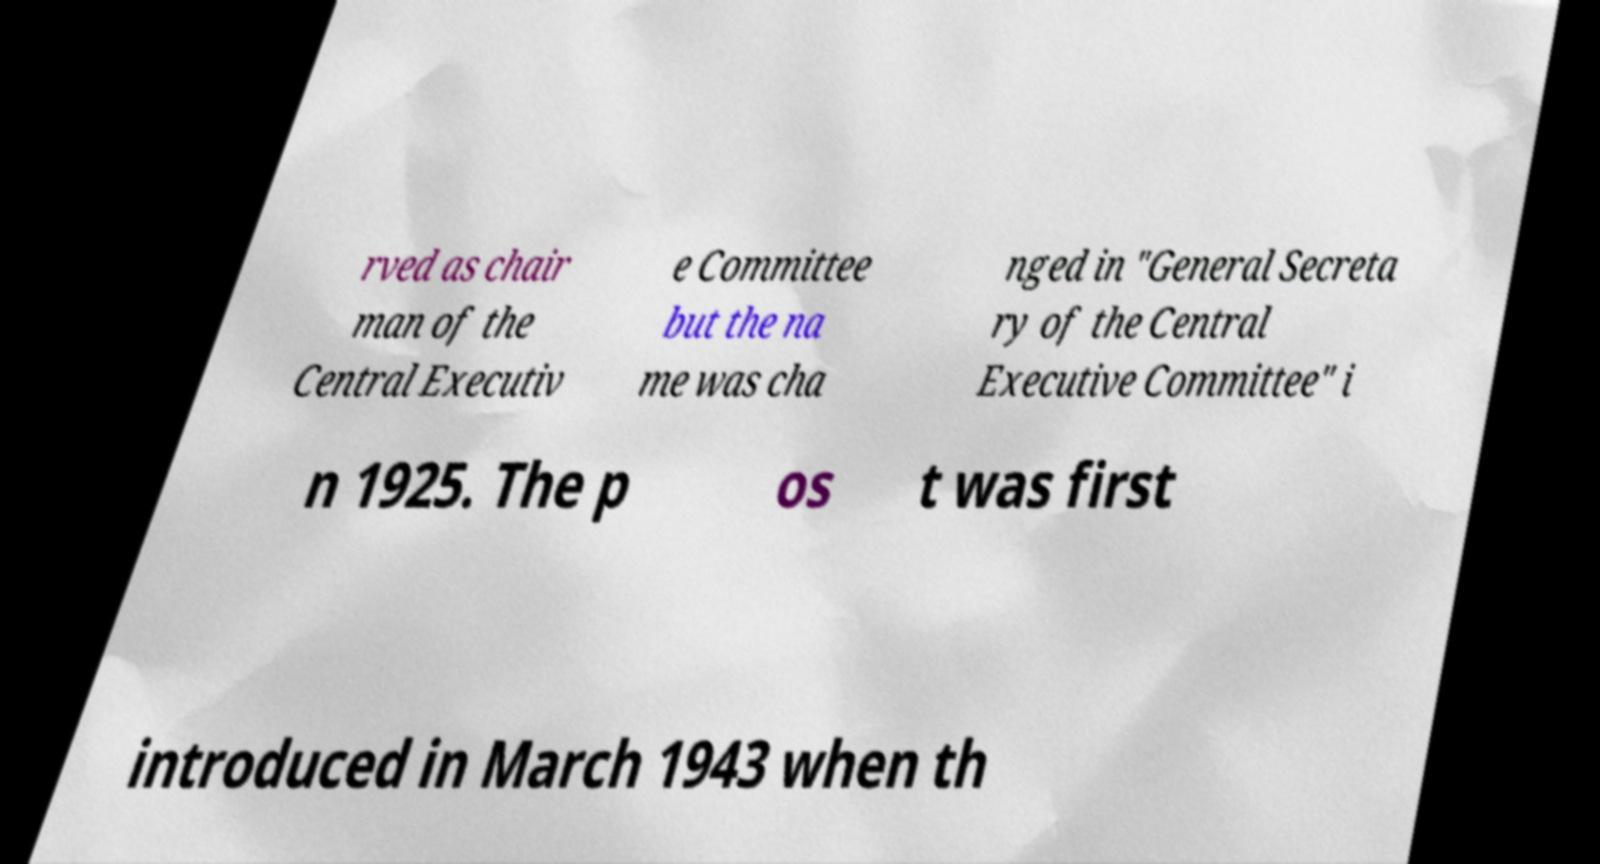What messages or text are displayed in this image? I need them in a readable, typed format. rved as chair man of the Central Executiv e Committee but the na me was cha nged in "General Secreta ry of the Central Executive Committee" i n 1925. The p os t was first introduced in March 1943 when th 